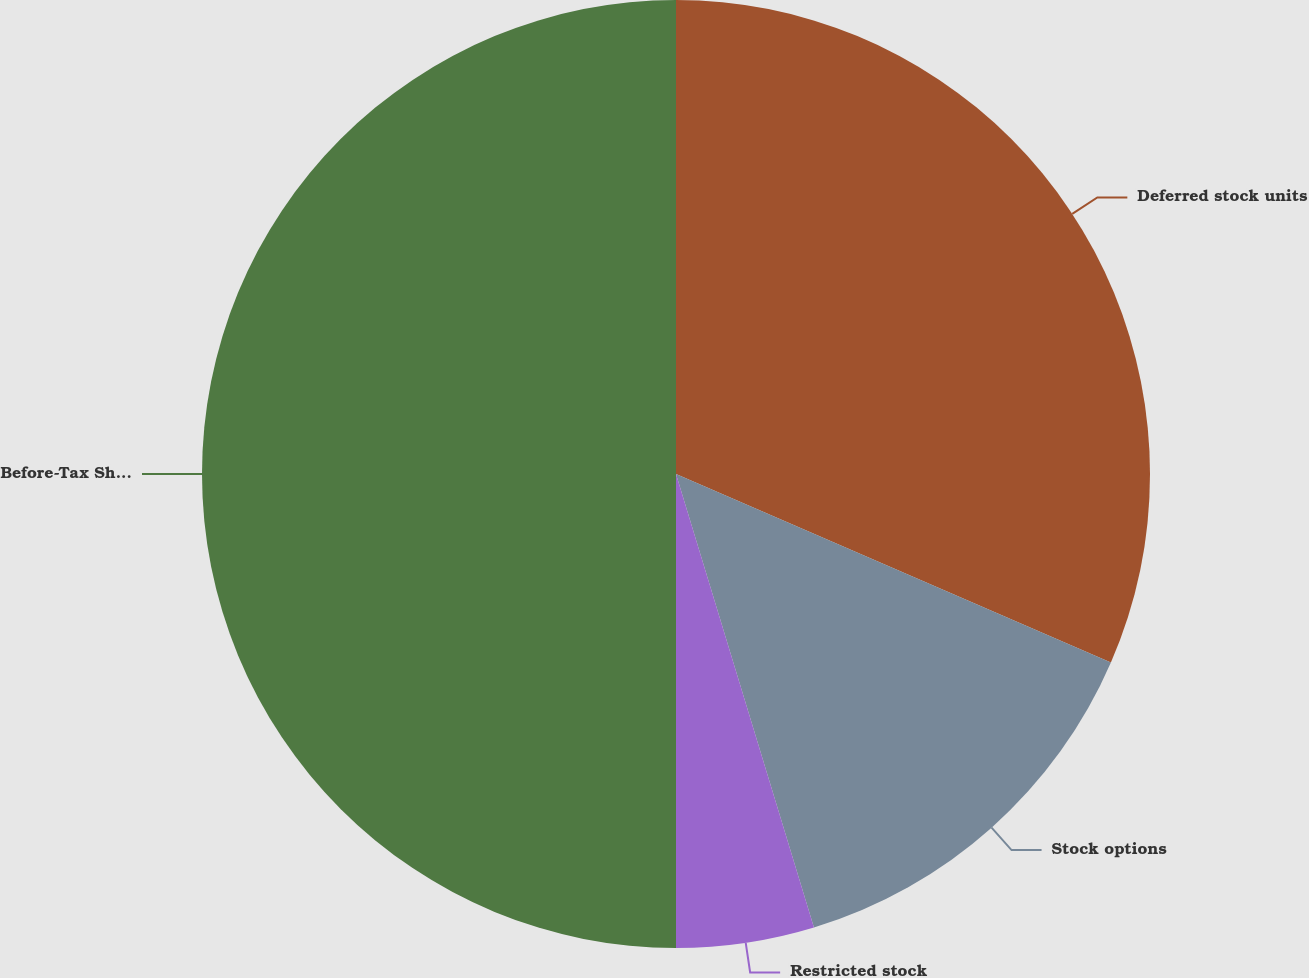Convert chart to OTSL. <chart><loc_0><loc_0><loc_500><loc_500><pie_chart><fcel>Deferred stock units<fcel>Stock options<fcel>Restricted stock<fcel>Before-Tax Share-Based<nl><fcel>31.51%<fcel>13.79%<fcel>4.7%<fcel>50.0%<nl></chart> 